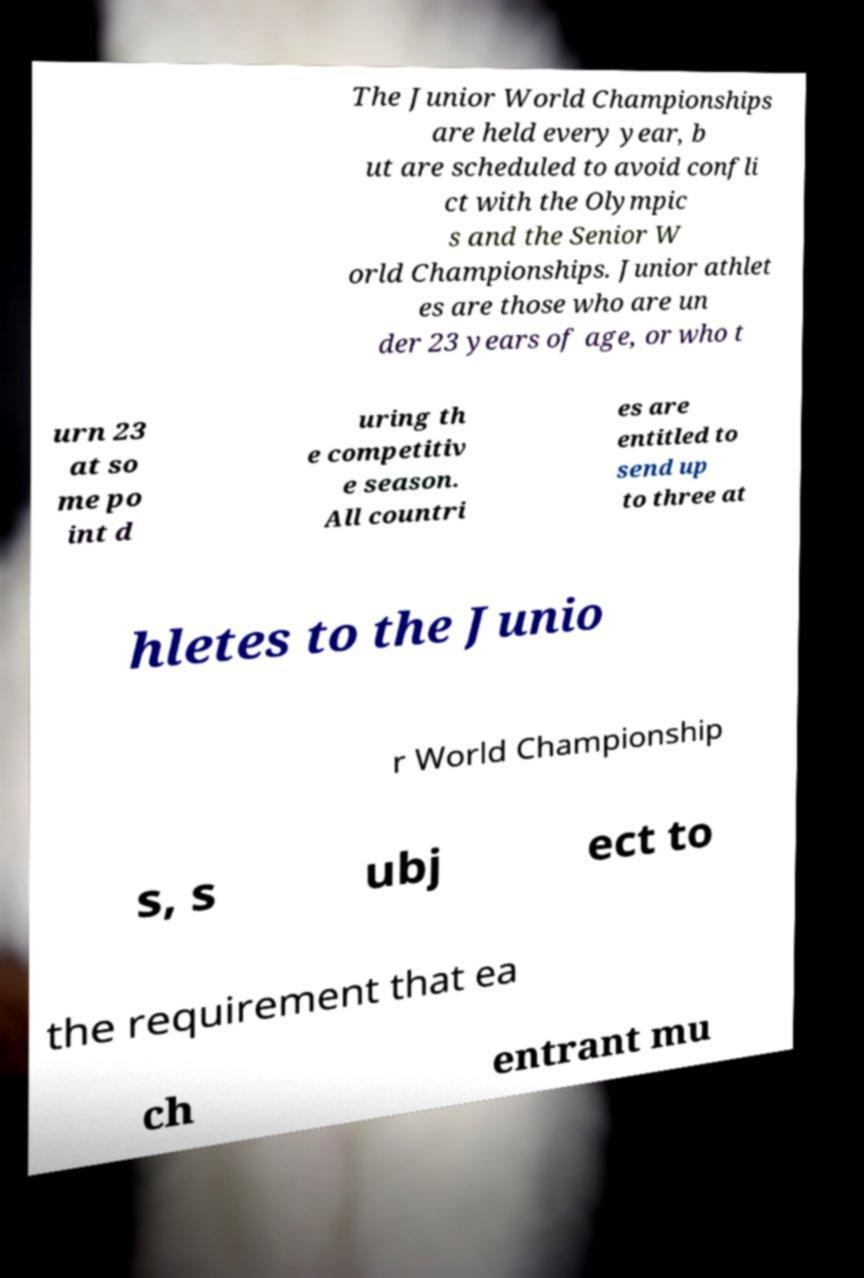Can you accurately transcribe the text from the provided image for me? The Junior World Championships are held every year, b ut are scheduled to avoid confli ct with the Olympic s and the Senior W orld Championships. Junior athlet es are those who are un der 23 years of age, or who t urn 23 at so me po int d uring th e competitiv e season. All countri es are entitled to send up to three at hletes to the Junio r World Championship s, s ubj ect to the requirement that ea ch entrant mu 